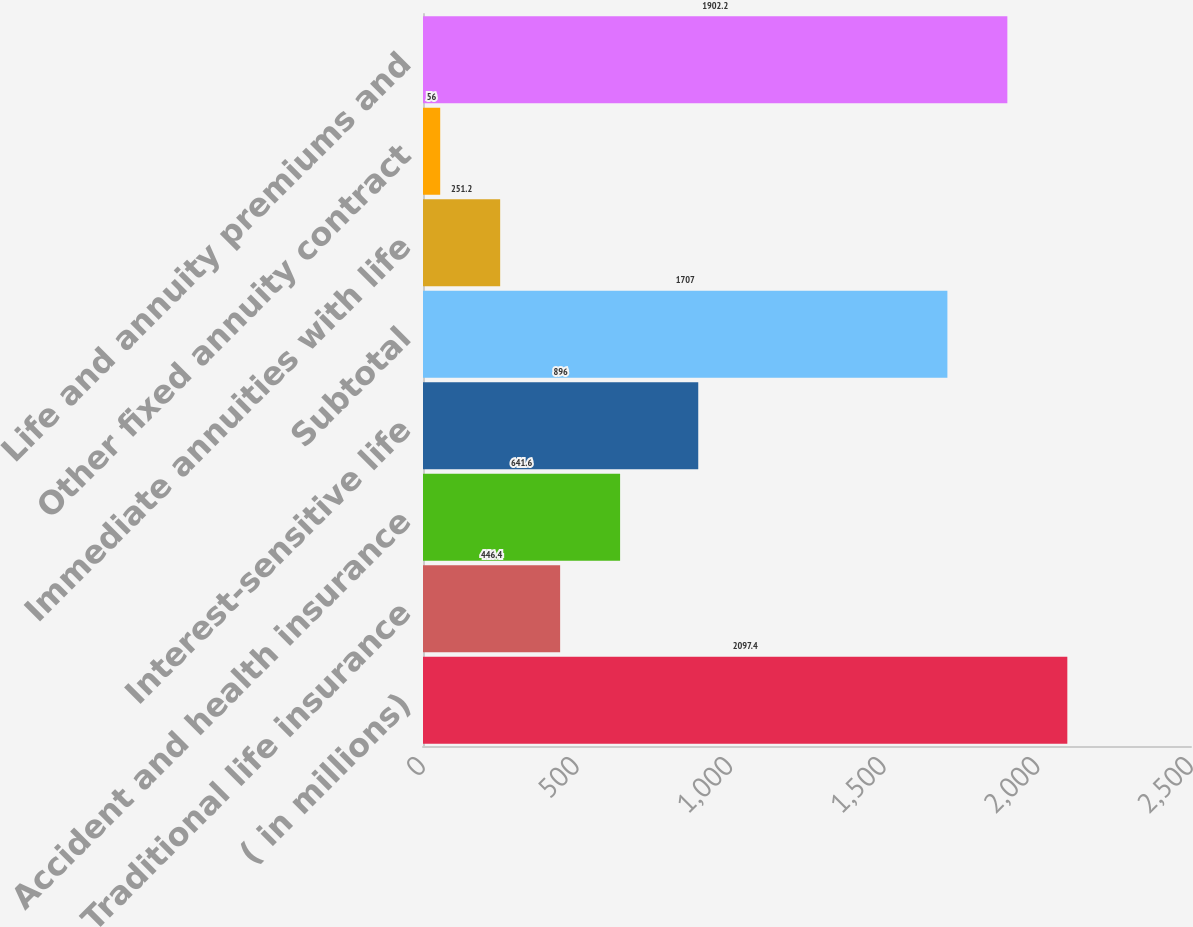Convert chart to OTSL. <chart><loc_0><loc_0><loc_500><loc_500><bar_chart><fcel>( in millions)<fcel>Traditional life insurance<fcel>Accident and health insurance<fcel>Interest-sensitive life<fcel>Subtotal<fcel>Immediate annuities with life<fcel>Other fixed annuity contract<fcel>Life and annuity premiums and<nl><fcel>2097.4<fcel>446.4<fcel>641.6<fcel>896<fcel>1707<fcel>251.2<fcel>56<fcel>1902.2<nl></chart> 